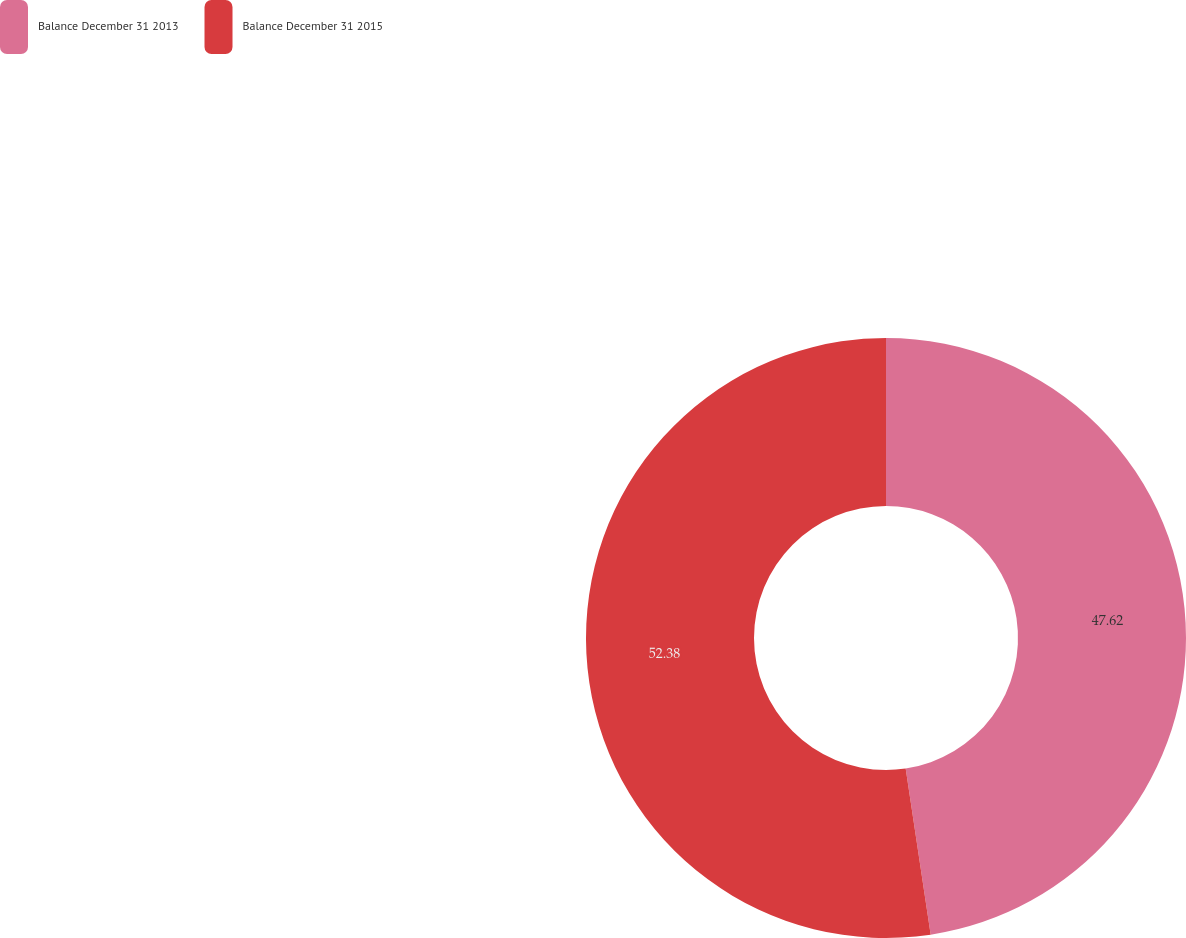Convert chart. <chart><loc_0><loc_0><loc_500><loc_500><pie_chart><fcel>Balance December 31 2013<fcel>Balance December 31 2015<nl><fcel>47.62%<fcel>52.38%<nl></chart> 